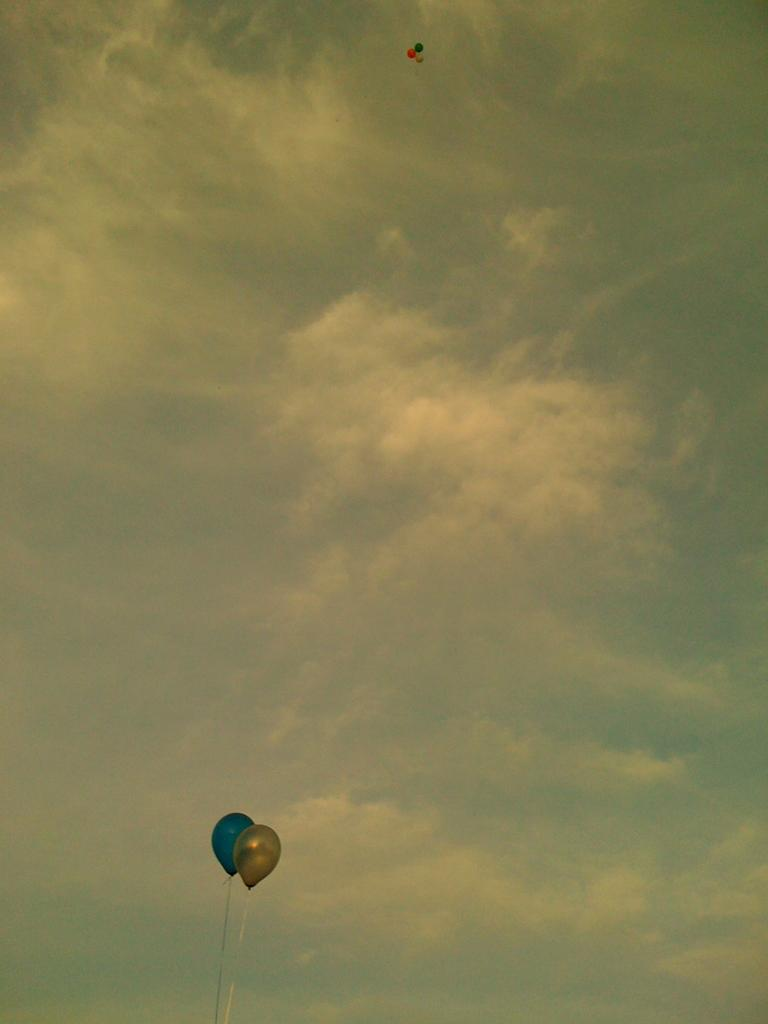What objects are present in the image? There are balloons in the image. What can be seen in the background of the image? The sky is visible in the background of the image. What is the condition of the sky in the image? Clouds are present in the sky. What type of calendar is hanging on the wall in the image? There is no wall or calendar present in the image; it only features balloons and the sky. 